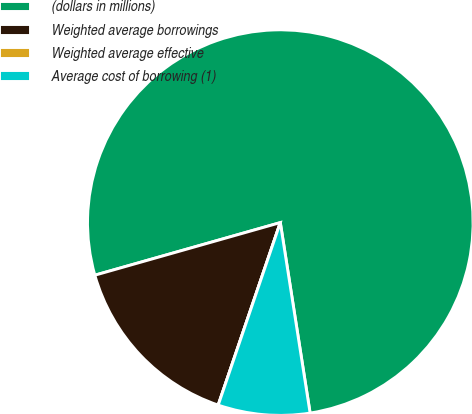Convert chart. <chart><loc_0><loc_0><loc_500><loc_500><pie_chart><fcel>(dollars in millions)<fcel>Weighted average borrowings<fcel>Weighted average effective<fcel>Average cost of borrowing (1)<nl><fcel>76.92%<fcel>15.38%<fcel>0.0%<fcel>7.69%<nl></chart> 